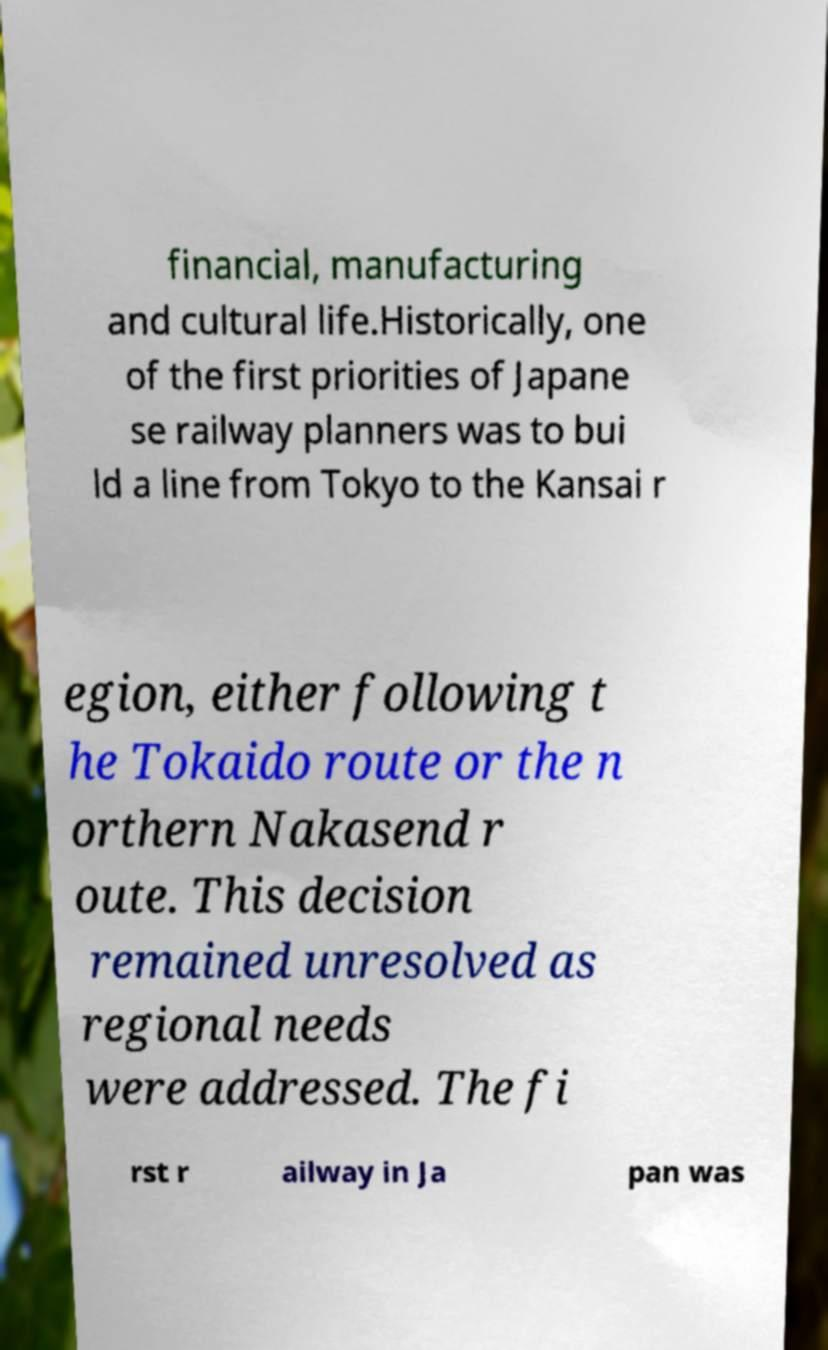Please identify and transcribe the text found in this image. financial, manufacturing and cultural life.Historically, one of the first priorities of Japane se railway planners was to bui ld a line from Tokyo to the Kansai r egion, either following t he Tokaido route or the n orthern Nakasend r oute. This decision remained unresolved as regional needs were addressed. The fi rst r ailway in Ja pan was 